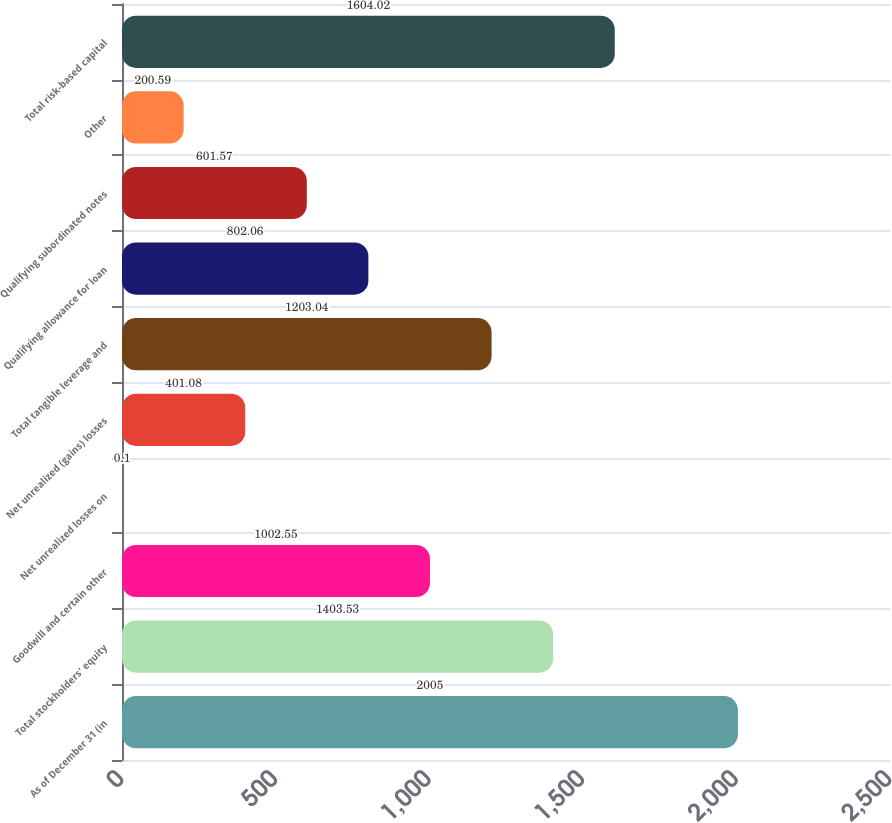Convert chart. <chart><loc_0><loc_0><loc_500><loc_500><bar_chart><fcel>As of December 31 (in<fcel>Total stockholders' equity<fcel>Goodwill and certain other<fcel>Net unrealized losses on<fcel>Net unrealized (gains) losses<fcel>Total tangible leverage and<fcel>Qualifying allowance for loan<fcel>Qualifying subordinated notes<fcel>Other<fcel>Total risk-based capital<nl><fcel>2005<fcel>1403.53<fcel>1002.55<fcel>0.1<fcel>401.08<fcel>1203.04<fcel>802.06<fcel>601.57<fcel>200.59<fcel>1604.02<nl></chart> 